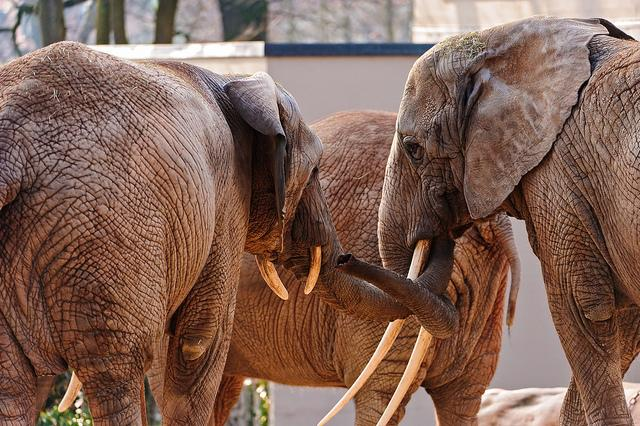How many big elephants are inside of this zoo enclosure together?

Choices:
A) one
B) four
C) two
D) three three 